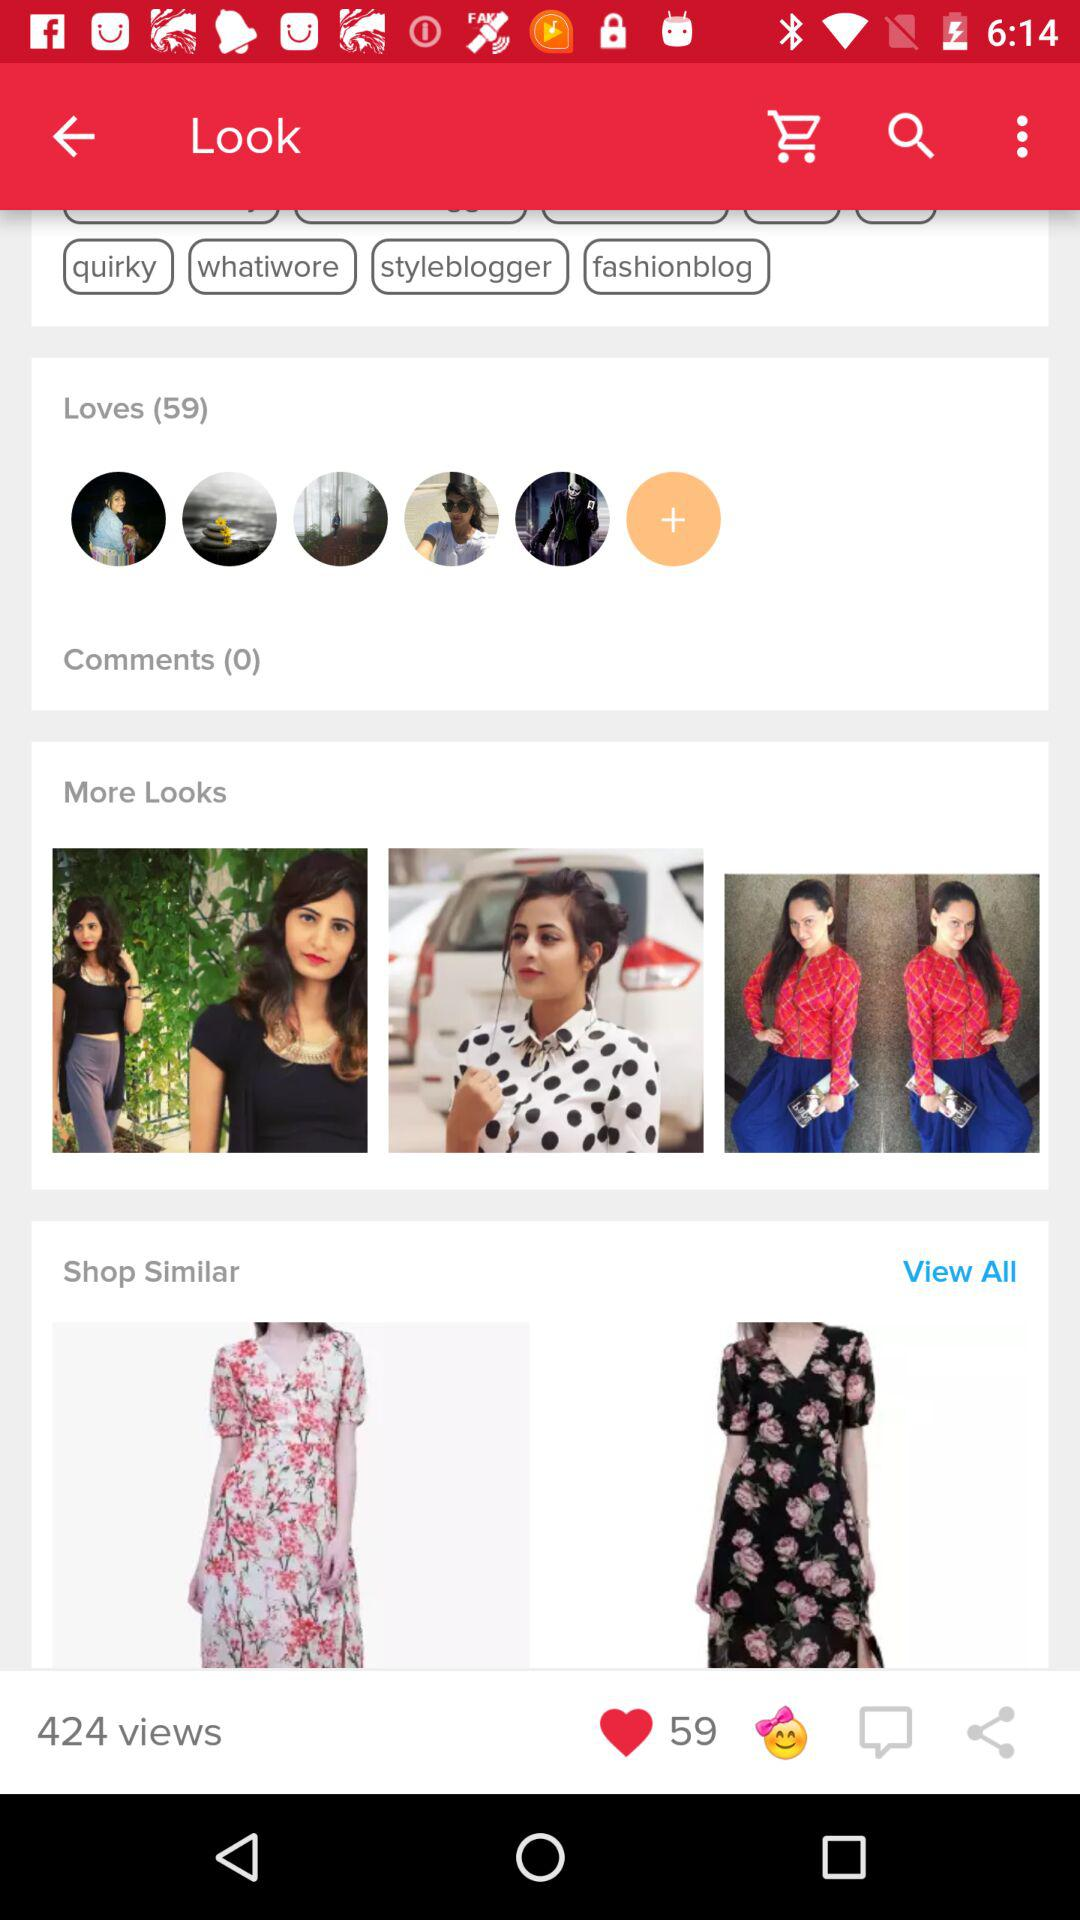What is the total count of views? The total count of views is 424. 